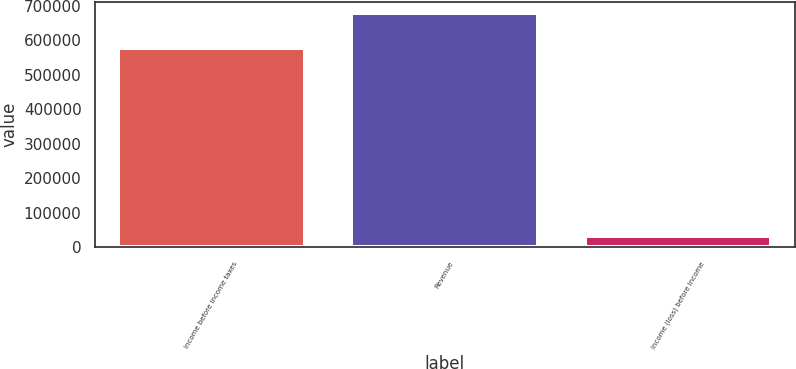Convert chart. <chart><loc_0><loc_0><loc_500><loc_500><bar_chart><fcel>Income before income taxes<fcel>Revenue<fcel>Income (loss) before income<nl><fcel>578500<fcel>677637<fcel>31901<nl></chart> 